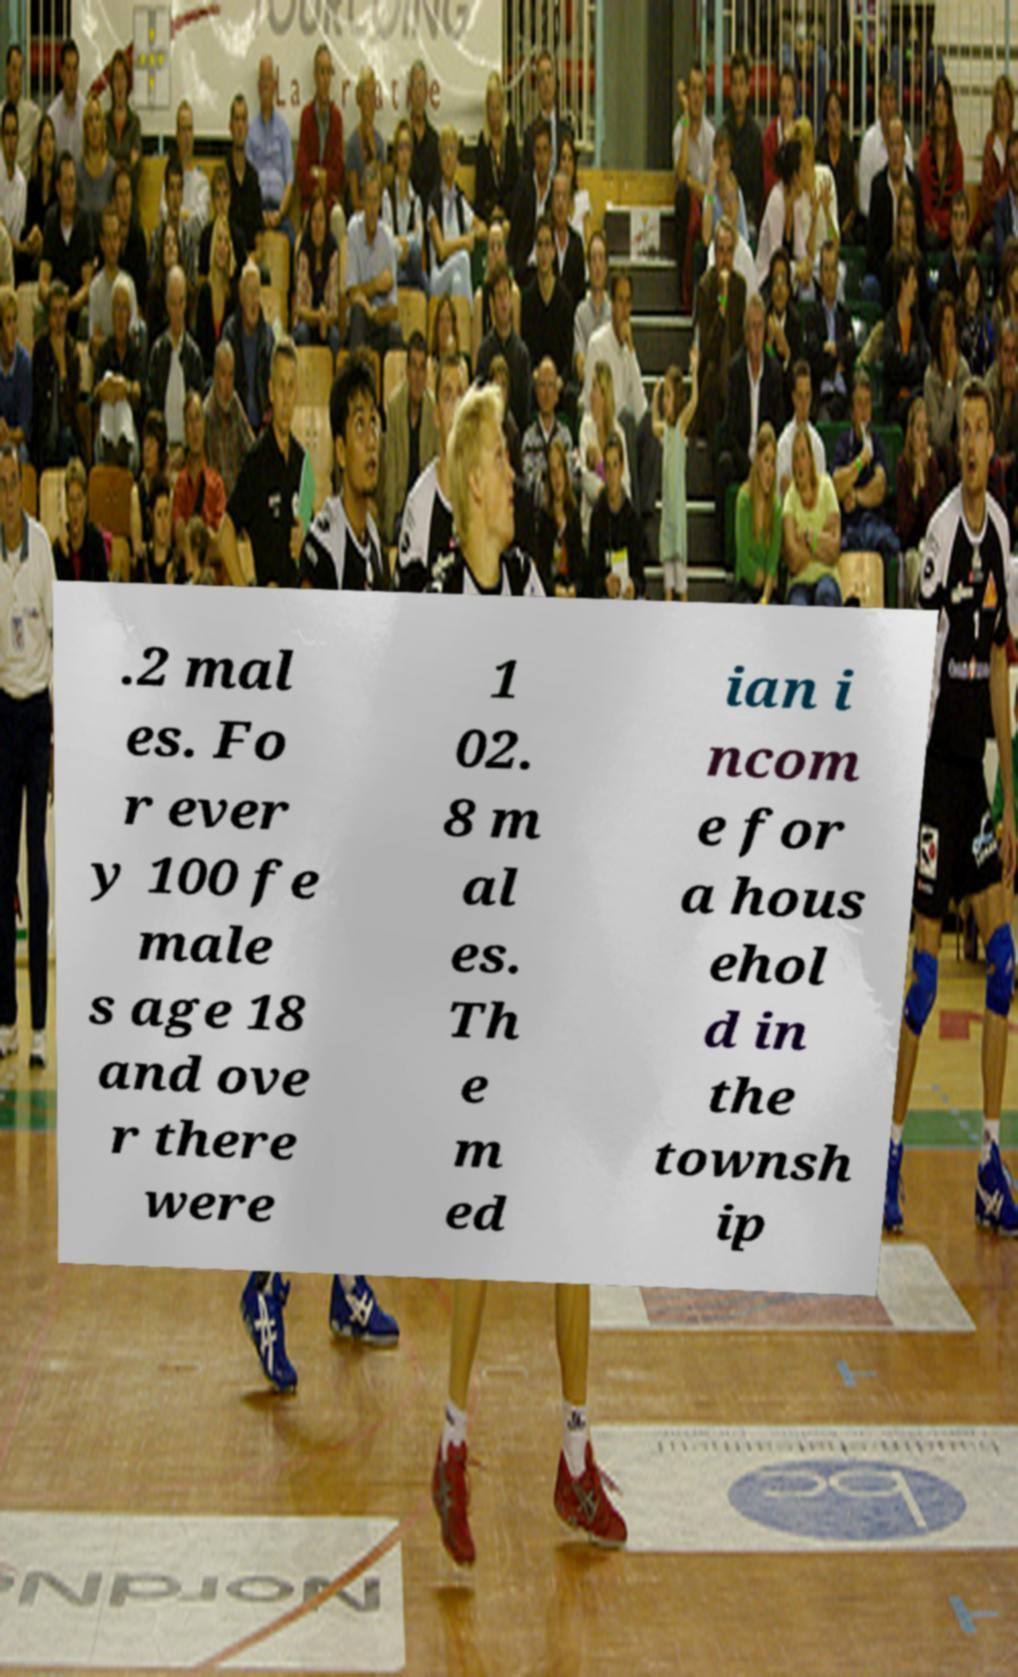What messages or text are displayed in this image? I need them in a readable, typed format. .2 mal es. Fo r ever y 100 fe male s age 18 and ove r there were 1 02. 8 m al es. Th e m ed ian i ncom e for a hous ehol d in the townsh ip 